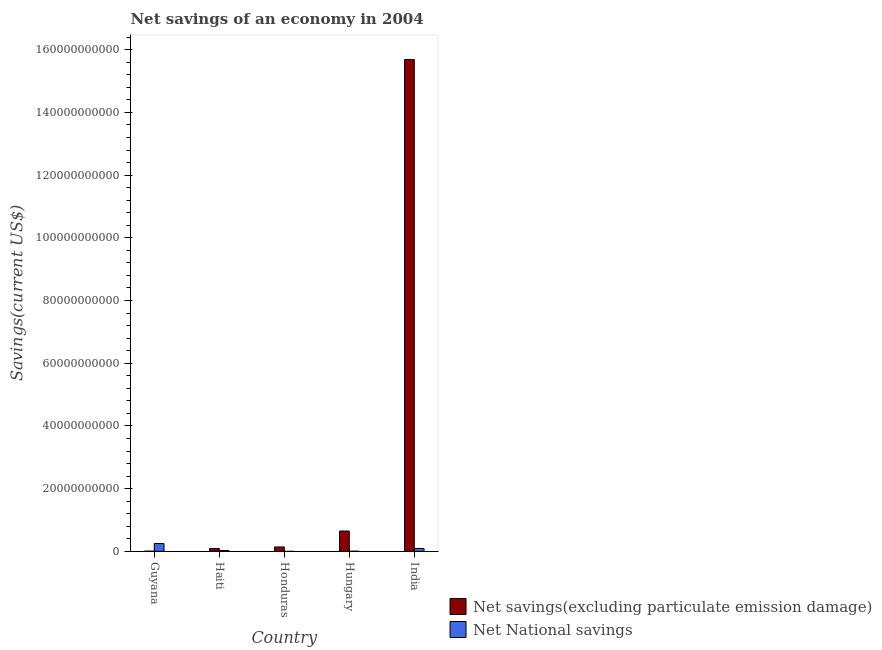How many bars are there on the 1st tick from the left?
Your answer should be very brief. 2. What is the label of the 4th group of bars from the left?
Make the answer very short. Hungary. In how many cases, is the number of bars for a given country not equal to the number of legend labels?
Your answer should be very brief. 1. What is the net savings(excluding particulate emission damage) in Hungary?
Provide a succinct answer. 6.49e+09. Across all countries, what is the maximum net savings(excluding particulate emission damage)?
Your answer should be very brief. 1.57e+11. In which country was the net national savings maximum?
Give a very brief answer. Guyana. What is the total net savings(excluding particulate emission damage) in the graph?
Your response must be concise. 1.66e+11. What is the difference between the net savings(excluding particulate emission damage) in Hungary and that in India?
Make the answer very short. -1.50e+11. What is the difference between the net savings(excluding particulate emission damage) in Honduras and the net national savings in India?
Provide a short and direct response. 4.80e+08. What is the average net savings(excluding particulate emission damage) per country?
Provide a short and direct response. 3.31e+1. What is the difference between the net national savings and net savings(excluding particulate emission damage) in Haiti?
Your answer should be very brief. -6.26e+08. What is the ratio of the net national savings in Haiti to that in Hungary?
Provide a short and direct response. 5.15. Is the net savings(excluding particulate emission damage) in Guyana less than that in Haiti?
Offer a very short reply. Yes. Is the difference between the net national savings in Guyana and Haiti greater than the difference between the net savings(excluding particulate emission damage) in Guyana and Haiti?
Make the answer very short. Yes. What is the difference between the highest and the second highest net savings(excluding particulate emission damage)?
Your answer should be very brief. 1.50e+11. What is the difference between the highest and the lowest net savings(excluding particulate emission damage)?
Offer a very short reply. 1.57e+11. In how many countries, is the net national savings greater than the average net national savings taken over all countries?
Your answer should be compact. 2. Is the sum of the net savings(excluding particulate emission damage) in Guyana and Haiti greater than the maximum net national savings across all countries?
Give a very brief answer. No. How many bars are there?
Ensure brevity in your answer.  9. What is the difference between two consecutive major ticks on the Y-axis?
Make the answer very short. 2.00e+1. Does the graph contain any zero values?
Provide a succinct answer. Yes. How many legend labels are there?
Ensure brevity in your answer.  2. What is the title of the graph?
Give a very brief answer. Net savings of an economy in 2004. Does "Urban" appear as one of the legend labels in the graph?
Provide a short and direct response. No. What is the label or title of the X-axis?
Offer a terse response. Country. What is the label or title of the Y-axis?
Ensure brevity in your answer.  Savings(current US$). What is the Savings(current US$) in Net savings(excluding particulate emission damage) in Guyana?
Provide a succinct answer. 6.17e+07. What is the Savings(current US$) of Net National savings in Guyana?
Make the answer very short. 2.50e+09. What is the Savings(current US$) of Net savings(excluding particulate emission damage) in Haiti?
Ensure brevity in your answer.  9.05e+08. What is the Savings(current US$) in Net National savings in Haiti?
Your answer should be very brief. 2.78e+08. What is the Savings(current US$) in Net savings(excluding particulate emission damage) in Honduras?
Keep it short and to the point. 1.41e+09. What is the Savings(current US$) in Net National savings in Honduras?
Offer a terse response. 0. What is the Savings(current US$) in Net savings(excluding particulate emission damage) in Hungary?
Ensure brevity in your answer.  6.49e+09. What is the Savings(current US$) of Net National savings in Hungary?
Your answer should be very brief. 5.40e+07. What is the Savings(current US$) in Net savings(excluding particulate emission damage) in India?
Ensure brevity in your answer.  1.57e+11. What is the Savings(current US$) of Net National savings in India?
Your answer should be very brief. 9.28e+08. Across all countries, what is the maximum Savings(current US$) of Net savings(excluding particulate emission damage)?
Keep it short and to the point. 1.57e+11. Across all countries, what is the maximum Savings(current US$) of Net National savings?
Give a very brief answer. 2.50e+09. Across all countries, what is the minimum Savings(current US$) in Net savings(excluding particulate emission damage)?
Give a very brief answer. 6.17e+07. What is the total Savings(current US$) in Net savings(excluding particulate emission damage) in the graph?
Give a very brief answer. 1.66e+11. What is the total Savings(current US$) in Net National savings in the graph?
Ensure brevity in your answer.  3.76e+09. What is the difference between the Savings(current US$) in Net savings(excluding particulate emission damage) in Guyana and that in Haiti?
Ensure brevity in your answer.  -8.43e+08. What is the difference between the Savings(current US$) of Net National savings in Guyana and that in Haiti?
Provide a short and direct response. 2.22e+09. What is the difference between the Savings(current US$) of Net savings(excluding particulate emission damage) in Guyana and that in Honduras?
Your answer should be very brief. -1.35e+09. What is the difference between the Savings(current US$) of Net savings(excluding particulate emission damage) in Guyana and that in Hungary?
Keep it short and to the point. -6.43e+09. What is the difference between the Savings(current US$) in Net National savings in Guyana and that in Hungary?
Your answer should be very brief. 2.44e+09. What is the difference between the Savings(current US$) of Net savings(excluding particulate emission damage) in Guyana and that in India?
Provide a succinct answer. -1.57e+11. What is the difference between the Savings(current US$) of Net National savings in Guyana and that in India?
Offer a very short reply. 1.57e+09. What is the difference between the Savings(current US$) in Net savings(excluding particulate emission damage) in Haiti and that in Honduras?
Your answer should be compact. -5.03e+08. What is the difference between the Savings(current US$) of Net savings(excluding particulate emission damage) in Haiti and that in Hungary?
Your response must be concise. -5.58e+09. What is the difference between the Savings(current US$) in Net National savings in Haiti and that in Hungary?
Give a very brief answer. 2.24e+08. What is the difference between the Savings(current US$) of Net savings(excluding particulate emission damage) in Haiti and that in India?
Offer a very short reply. -1.56e+11. What is the difference between the Savings(current US$) in Net National savings in Haiti and that in India?
Ensure brevity in your answer.  -6.49e+08. What is the difference between the Savings(current US$) of Net savings(excluding particulate emission damage) in Honduras and that in Hungary?
Your response must be concise. -5.08e+09. What is the difference between the Savings(current US$) of Net savings(excluding particulate emission damage) in Honduras and that in India?
Your response must be concise. -1.55e+11. What is the difference between the Savings(current US$) of Net savings(excluding particulate emission damage) in Hungary and that in India?
Offer a terse response. -1.50e+11. What is the difference between the Savings(current US$) in Net National savings in Hungary and that in India?
Provide a short and direct response. -8.74e+08. What is the difference between the Savings(current US$) of Net savings(excluding particulate emission damage) in Guyana and the Savings(current US$) of Net National savings in Haiti?
Give a very brief answer. -2.17e+08. What is the difference between the Savings(current US$) of Net savings(excluding particulate emission damage) in Guyana and the Savings(current US$) of Net National savings in Hungary?
Ensure brevity in your answer.  7.65e+06. What is the difference between the Savings(current US$) in Net savings(excluding particulate emission damage) in Guyana and the Savings(current US$) in Net National savings in India?
Offer a very short reply. -8.66e+08. What is the difference between the Savings(current US$) in Net savings(excluding particulate emission damage) in Haiti and the Savings(current US$) in Net National savings in Hungary?
Your answer should be very brief. 8.51e+08. What is the difference between the Savings(current US$) of Net savings(excluding particulate emission damage) in Haiti and the Savings(current US$) of Net National savings in India?
Ensure brevity in your answer.  -2.32e+07. What is the difference between the Savings(current US$) in Net savings(excluding particulate emission damage) in Honduras and the Savings(current US$) in Net National savings in Hungary?
Your response must be concise. 1.35e+09. What is the difference between the Savings(current US$) of Net savings(excluding particulate emission damage) in Honduras and the Savings(current US$) of Net National savings in India?
Make the answer very short. 4.80e+08. What is the difference between the Savings(current US$) of Net savings(excluding particulate emission damage) in Hungary and the Savings(current US$) of Net National savings in India?
Your answer should be compact. 5.56e+09. What is the average Savings(current US$) of Net savings(excluding particulate emission damage) per country?
Give a very brief answer. 3.31e+1. What is the average Savings(current US$) in Net National savings per country?
Offer a very short reply. 7.51e+08. What is the difference between the Savings(current US$) in Net savings(excluding particulate emission damage) and Savings(current US$) in Net National savings in Guyana?
Offer a terse response. -2.43e+09. What is the difference between the Savings(current US$) of Net savings(excluding particulate emission damage) and Savings(current US$) of Net National savings in Haiti?
Your response must be concise. 6.26e+08. What is the difference between the Savings(current US$) of Net savings(excluding particulate emission damage) and Savings(current US$) of Net National savings in Hungary?
Provide a succinct answer. 6.43e+09. What is the difference between the Savings(current US$) in Net savings(excluding particulate emission damage) and Savings(current US$) in Net National savings in India?
Keep it short and to the point. 1.56e+11. What is the ratio of the Savings(current US$) of Net savings(excluding particulate emission damage) in Guyana to that in Haiti?
Provide a short and direct response. 0.07. What is the ratio of the Savings(current US$) of Net National savings in Guyana to that in Haiti?
Your answer should be very brief. 8.97. What is the ratio of the Savings(current US$) in Net savings(excluding particulate emission damage) in Guyana to that in Honduras?
Ensure brevity in your answer.  0.04. What is the ratio of the Savings(current US$) of Net savings(excluding particulate emission damage) in Guyana to that in Hungary?
Provide a succinct answer. 0.01. What is the ratio of the Savings(current US$) in Net National savings in Guyana to that in Hungary?
Your response must be concise. 46.18. What is the ratio of the Savings(current US$) of Net savings(excluding particulate emission damage) in Guyana to that in India?
Give a very brief answer. 0. What is the ratio of the Savings(current US$) of Net National savings in Guyana to that in India?
Provide a succinct answer. 2.69. What is the ratio of the Savings(current US$) in Net savings(excluding particulate emission damage) in Haiti to that in Honduras?
Provide a succinct answer. 0.64. What is the ratio of the Savings(current US$) in Net savings(excluding particulate emission damage) in Haiti to that in Hungary?
Offer a very short reply. 0.14. What is the ratio of the Savings(current US$) of Net National savings in Haiti to that in Hungary?
Your answer should be very brief. 5.15. What is the ratio of the Savings(current US$) of Net savings(excluding particulate emission damage) in Haiti to that in India?
Offer a very short reply. 0.01. What is the ratio of the Savings(current US$) of Net National savings in Haiti to that in India?
Your answer should be very brief. 0.3. What is the ratio of the Savings(current US$) in Net savings(excluding particulate emission damage) in Honduras to that in Hungary?
Offer a terse response. 0.22. What is the ratio of the Savings(current US$) in Net savings(excluding particulate emission damage) in Honduras to that in India?
Your answer should be very brief. 0.01. What is the ratio of the Savings(current US$) in Net savings(excluding particulate emission damage) in Hungary to that in India?
Make the answer very short. 0.04. What is the ratio of the Savings(current US$) of Net National savings in Hungary to that in India?
Your response must be concise. 0.06. What is the difference between the highest and the second highest Savings(current US$) in Net savings(excluding particulate emission damage)?
Offer a terse response. 1.50e+11. What is the difference between the highest and the second highest Savings(current US$) of Net National savings?
Provide a short and direct response. 1.57e+09. What is the difference between the highest and the lowest Savings(current US$) in Net savings(excluding particulate emission damage)?
Offer a terse response. 1.57e+11. What is the difference between the highest and the lowest Savings(current US$) in Net National savings?
Your answer should be compact. 2.50e+09. 